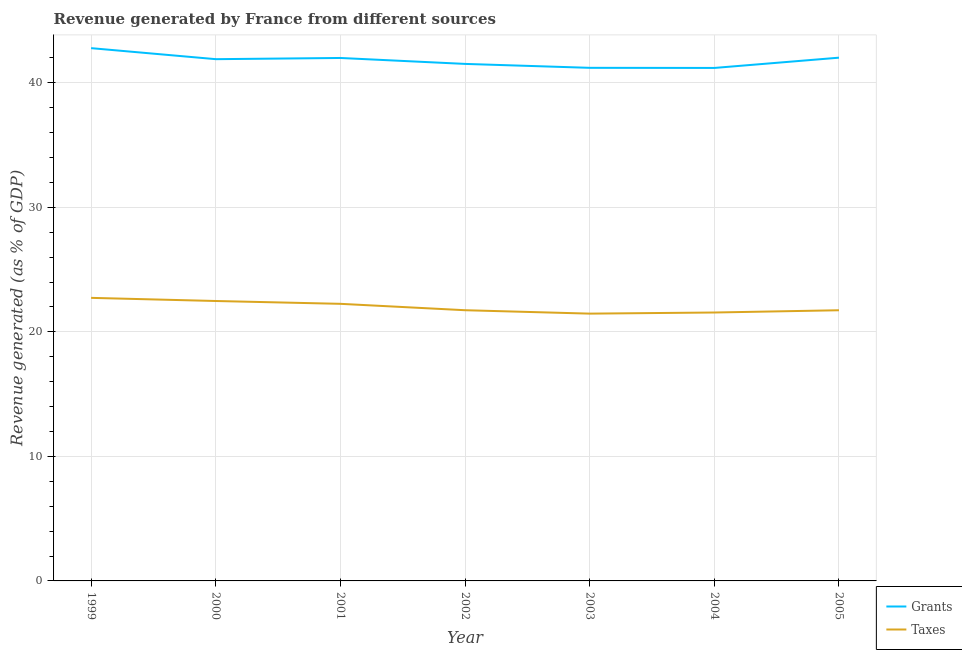Is the number of lines equal to the number of legend labels?
Your response must be concise. Yes. What is the revenue generated by taxes in 2002?
Your response must be concise. 21.74. Across all years, what is the maximum revenue generated by grants?
Provide a short and direct response. 42.78. Across all years, what is the minimum revenue generated by grants?
Make the answer very short. 41.19. What is the total revenue generated by grants in the graph?
Keep it short and to the point. 292.58. What is the difference between the revenue generated by taxes in 2004 and that in 2005?
Your response must be concise. -0.18. What is the difference between the revenue generated by grants in 2000 and the revenue generated by taxes in 2005?
Offer a terse response. 20.16. What is the average revenue generated by taxes per year?
Offer a terse response. 21.99. In the year 2004, what is the difference between the revenue generated by grants and revenue generated by taxes?
Ensure brevity in your answer.  19.64. What is the ratio of the revenue generated by taxes in 2002 to that in 2004?
Keep it short and to the point. 1.01. Is the revenue generated by grants in 2001 less than that in 2002?
Your response must be concise. No. Is the difference between the revenue generated by taxes in 1999 and 2000 greater than the difference between the revenue generated by grants in 1999 and 2000?
Your response must be concise. No. What is the difference between the highest and the second highest revenue generated by taxes?
Make the answer very short. 0.25. What is the difference between the highest and the lowest revenue generated by taxes?
Give a very brief answer. 1.27. Does the revenue generated by taxes monotonically increase over the years?
Your answer should be compact. No. Is the revenue generated by taxes strictly less than the revenue generated by grants over the years?
Make the answer very short. Yes. Are the values on the major ticks of Y-axis written in scientific E-notation?
Make the answer very short. No. Does the graph contain any zero values?
Give a very brief answer. No. Does the graph contain grids?
Offer a very short reply. Yes. Where does the legend appear in the graph?
Give a very brief answer. Bottom right. What is the title of the graph?
Give a very brief answer. Revenue generated by France from different sources. Does "Researchers" appear as one of the legend labels in the graph?
Your answer should be compact. No. What is the label or title of the Y-axis?
Provide a succinct answer. Revenue generated (as % of GDP). What is the Revenue generated (as % of GDP) of Grants in 1999?
Make the answer very short. 42.78. What is the Revenue generated (as % of GDP) in Taxes in 1999?
Offer a very short reply. 22.73. What is the Revenue generated (as % of GDP) of Grants in 2000?
Provide a short and direct response. 41.89. What is the Revenue generated (as % of GDP) of Taxes in 2000?
Offer a terse response. 22.48. What is the Revenue generated (as % of GDP) in Grants in 2001?
Offer a terse response. 41.99. What is the Revenue generated (as % of GDP) in Taxes in 2001?
Offer a very short reply. 22.25. What is the Revenue generated (as % of GDP) in Grants in 2002?
Offer a terse response. 41.51. What is the Revenue generated (as % of GDP) in Taxes in 2002?
Your response must be concise. 21.74. What is the Revenue generated (as % of GDP) in Grants in 2003?
Keep it short and to the point. 41.2. What is the Revenue generated (as % of GDP) in Taxes in 2003?
Give a very brief answer. 21.46. What is the Revenue generated (as % of GDP) of Grants in 2004?
Provide a succinct answer. 41.19. What is the Revenue generated (as % of GDP) of Taxes in 2004?
Provide a succinct answer. 21.55. What is the Revenue generated (as % of GDP) of Grants in 2005?
Give a very brief answer. 42.01. What is the Revenue generated (as % of GDP) of Taxes in 2005?
Provide a short and direct response. 21.73. Across all years, what is the maximum Revenue generated (as % of GDP) of Grants?
Give a very brief answer. 42.78. Across all years, what is the maximum Revenue generated (as % of GDP) of Taxes?
Provide a short and direct response. 22.73. Across all years, what is the minimum Revenue generated (as % of GDP) in Grants?
Your answer should be very brief. 41.19. Across all years, what is the minimum Revenue generated (as % of GDP) in Taxes?
Your answer should be compact. 21.46. What is the total Revenue generated (as % of GDP) in Grants in the graph?
Ensure brevity in your answer.  292.58. What is the total Revenue generated (as % of GDP) in Taxes in the graph?
Give a very brief answer. 153.94. What is the difference between the Revenue generated (as % of GDP) of Grants in 1999 and that in 2000?
Your answer should be compact. 0.88. What is the difference between the Revenue generated (as % of GDP) in Taxes in 1999 and that in 2000?
Offer a terse response. 0.25. What is the difference between the Revenue generated (as % of GDP) in Grants in 1999 and that in 2001?
Ensure brevity in your answer.  0.79. What is the difference between the Revenue generated (as % of GDP) of Taxes in 1999 and that in 2001?
Give a very brief answer. 0.48. What is the difference between the Revenue generated (as % of GDP) of Grants in 1999 and that in 2002?
Your answer should be very brief. 1.27. What is the difference between the Revenue generated (as % of GDP) of Taxes in 1999 and that in 2002?
Your response must be concise. 0.99. What is the difference between the Revenue generated (as % of GDP) of Grants in 1999 and that in 2003?
Your answer should be very brief. 1.58. What is the difference between the Revenue generated (as % of GDP) in Taxes in 1999 and that in 2003?
Ensure brevity in your answer.  1.27. What is the difference between the Revenue generated (as % of GDP) of Grants in 1999 and that in 2004?
Your answer should be compact. 1.59. What is the difference between the Revenue generated (as % of GDP) of Taxes in 1999 and that in 2004?
Make the answer very short. 1.18. What is the difference between the Revenue generated (as % of GDP) in Grants in 1999 and that in 2005?
Offer a terse response. 0.76. What is the difference between the Revenue generated (as % of GDP) of Grants in 2000 and that in 2001?
Give a very brief answer. -0.1. What is the difference between the Revenue generated (as % of GDP) of Taxes in 2000 and that in 2001?
Your answer should be very brief. 0.23. What is the difference between the Revenue generated (as % of GDP) of Grants in 2000 and that in 2002?
Your response must be concise. 0.38. What is the difference between the Revenue generated (as % of GDP) in Taxes in 2000 and that in 2002?
Provide a succinct answer. 0.74. What is the difference between the Revenue generated (as % of GDP) in Grants in 2000 and that in 2003?
Your answer should be compact. 0.7. What is the difference between the Revenue generated (as % of GDP) in Taxes in 2000 and that in 2003?
Make the answer very short. 1.01. What is the difference between the Revenue generated (as % of GDP) of Grants in 2000 and that in 2004?
Provide a short and direct response. 0.7. What is the difference between the Revenue generated (as % of GDP) of Taxes in 2000 and that in 2004?
Keep it short and to the point. 0.92. What is the difference between the Revenue generated (as % of GDP) in Grants in 2000 and that in 2005?
Offer a terse response. -0.12. What is the difference between the Revenue generated (as % of GDP) in Taxes in 2000 and that in 2005?
Make the answer very short. 0.74. What is the difference between the Revenue generated (as % of GDP) in Grants in 2001 and that in 2002?
Offer a terse response. 0.48. What is the difference between the Revenue generated (as % of GDP) in Taxes in 2001 and that in 2002?
Offer a very short reply. 0.51. What is the difference between the Revenue generated (as % of GDP) of Grants in 2001 and that in 2003?
Make the answer very short. 0.79. What is the difference between the Revenue generated (as % of GDP) of Taxes in 2001 and that in 2003?
Your answer should be compact. 0.79. What is the difference between the Revenue generated (as % of GDP) in Grants in 2001 and that in 2004?
Give a very brief answer. 0.8. What is the difference between the Revenue generated (as % of GDP) in Taxes in 2001 and that in 2004?
Make the answer very short. 0.7. What is the difference between the Revenue generated (as % of GDP) in Grants in 2001 and that in 2005?
Give a very brief answer. -0.02. What is the difference between the Revenue generated (as % of GDP) of Taxes in 2001 and that in 2005?
Offer a terse response. 0.52. What is the difference between the Revenue generated (as % of GDP) of Grants in 2002 and that in 2003?
Ensure brevity in your answer.  0.32. What is the difference between the Revenue generated (as % of GDP) of Taxes in 2002 and that in 2003?
Offer a very short reply. 0.27. What is the difference between the Revenue generated (as % of GDP) of Grants in 2002 and that in 2004?
Your response must be concise. 0.32. What is the difference between the Revenue generated (as % of GDP) of Taxes in 2002 and that in 2004?
Your answer should be very brief. 0.18. What is the difference between the Revenue generated (as % of GDP) of Grants in 2002 and that in 2005?
Your response must be concise. -0.5. What is the difference between the Revenue generated (as % of GDP) of Taxes in 2002 and that in 2005?
Provide a succinct answer. 0. What is the difference between the Revenue generated (as % of GDP) of Grants in 2003 and that in 2004?
Your response must be concise. 0.01. What is the difference between the Revenue generated (as % of GDP) in Taxes in 2003 and that in 2004?
Offer a very short reply. -0.09. What is the difference between the Revenue generated (as % of GDP) of Grants in 2003 and that in 2005?
Ensure brevity in your answer.  -0.82. What is the difference between the Revenue generated (as % of GDP) in Taxes in 2003 and that in 2005?
Keep it short and to the point. -0.27. What is the difference between the Revenue generated (as % of GDP) in Grants in 2004 and that in 2005?
Provide a short and direct response. -0.82. What is the difference between the Revenue generated (as % of GDP) of Taxes in 2004 and that in 2005?
Offer a very short reply. -0.18. What is the difference between the Revenue generated (as % of GDP) of Grants in 1999 and the Revenue generated (as % of GDP) of Taxes in 2000?
Keep it short and to the point. 20.3. What is the difference between the Revenue generated (as % of GDP) in Grants in 1999 and the Revenue generated (as % of GDP) in Taxes in 2001?
Offer a terse response. 20.53. What is the difference between the Revenue generated (as % of GDP) in Grants in 1999 and the Revenue generated (as % of GDP) in Taxes in 2002?
Your answer should be very brief. 21.04. What is the difference between the Revenue generated (as % of GDP) in Grants in 1999 and the Revenue generated (as % of GDP) in Taxes in 2003?
Your answer should be compact. 21.32. What is the difference between the Revenue generated (as % of GDP) in Grants in 1999 and the Revenue generated (as % of GDP) in Taxes in 2004?
Ensure brevity in your answer.  21.23. What is the difference between the Revenue generated (as % of GDP) in Grants in 1999 and the Revenue generated (as % of GDP) in Taxes in 2005?
Give a very brief answer. 21.05. What is the difference between the Revenue generated (as % of GDP) in Grants in 2000 and the Revenue generated (as % of GDP) in Taxes in 2001?
Make the answer very short. 19.65. What is the difference between the Revenue generated (as % of GDP) in Grants in 2000 and the Revenue generated (as % of GDP) in Taxes in 2002?
Your answer should be compact. 20.16. What is the difference between the Revenue generated (as % of GDP) of Grants in 2000 and the Revenue generated (as % of GDP) of Taxes in 2003?
Give a very brief answer. 20.43. What is the difference between the Revenue generated (as % of GDP) in Grants in 2000 and the Revenue generated (as % of GDP) in Taxes in 2004?
Provide a succinct answer. 20.34. What is the difference between the Revenue generated (as % of GDP) of Grants in 2000 and the Revenue generated (as % of GDP) of Taxes in 2005?
Offer a very short reply. 20.16. What is the difference between the Revenue generated (as % of GDP) in Grants in 2001 and the Revenue generated (as % of GDP) in Taxes in 2002?
Your response must be concise. 20.25. What is the difference between the Revenue generated (as % of GDP) of Grants in 2001 and the Revenue generated (as % of GDP) of Taxes in 2003?
Provide a succinct answer. 20.53. What is the difference between the Revenue generated (as % of GDP) in Grants in 2001 and the Revenue generated (as % of GDP) in Taxes in 2004?
Provide a short and direct response. 20.44. What is the difference between the Revenue generated (as % of GDP) of Grants in 2001 and the Revenue generated (as % of GDP) of Taxes in 2005?
Offer a terse response. 20.26. What is the difference between the Revenue generated (as % of GDP) of Grants in 2002 and the Revenue generated (as % of GDP) of Taxes in 2003?
Your answer should be very brief. 20.05. What is the difference between the Revenue generated (as % of GDP) in Grants in 2002 and the Revenue generated (as % of GDP) in Taxes in 2004?
Your answer should be very brief. 19.96. What is the difference between the Revenue generated (as % of GDP) in Grants in 2002 and the Revenue generated (as % of GDP) in Taxes in 2005?
Offer a very short reply. 19.78. What is the difference between the Revenue generated (as % of GDP) in Grants in 2003 and the Revenue generated (as % of GDP) in Taxes in 2004?
Your answer should be very brief. 19.65. What is the difference between the Revenue generated (as % of GDP) of Grants in 2003 and the Revenue generated (as % of GDP) of Taxes in 2005?
Give a very brief answer. 19.46. What is the difference between the Revenue generated (as % of GDP) in Grants in 2004 and the Revenue generated (as % of GDP) in Taxes in 2005?
Provide a short and direct response. 19.46. What is the average Revenue generated (as % of GDP) of Grants per year?
Give a very brief answer. 41.8. What is the average Revenue generated (as % of GDP) of Taxes per year?
Make the answer very short. 21.99. In the year 1999, what is the difference between the Revenue generated (as % of GDP) of Grants and Revenue generated (as % of GDP) of Taxes?
Make the answer very short. 20.05. In the year 2000, what is the difference between the Revenue generated (as % of GDP) in Grants and Revenue generated (as % of GDP) in Taxes?
Give a very brief answer. 19.42. In the year 2001, what is the difference between the Revenue generated (as % of GDP) in Grants and Revenue generated (as % of GDP) in Taxes?
Provide a short and direct response. 19.74. In the year 2002, what is the difference between the Revenue generated (as % of GDP) in Grants and Revenue generated (as % of GDP) in Taxes?
Your answer should be compact. 19.78. In the year 2003, what is the difference between the Revenue generated (as % of GDP) of Grants and Revenue generated (as % of GDP) of Taxes?
Provide a succinct answer. 19.74. In the year 2004, what is the difference between the Revenue generated (as % of GDP) in Grants and Revenue generated (as % of GDP) in Taxes?
Offer a very short reply. 19.64. In the year 2005, what is the difference between the Revenue generated (as % of GDP) in Grants and Revenue generated (as % of GDP) in Taxes?
Provide a short and direct response. 20.28. What is the ratio of the Revenue generated (as % of GDP) of Grants in 1999 to that in 2000?
Offer a very short reply. 1.02. What is the ratio of the Revenue generated (as % of GDP) of Taxes in 1999 to that in 2000?
Give a very brief answer. 1.01. What is the ratio of the Revenue generated (as % of GDP) in Grants in 1999 to that in 2001?
Your response must be concise. 1.02. What is the ratio of the Revenue generated (as % of GDP) of Taxes in 1999 to that in 2001?
Provide a short and direct response. 1.02. What is the ratio of the Revenue generated (as % of GDP) in Grants in 1999 to that in 2002?
Your answer should be compact. 1.03. What is the ratio of the Revenue generated (as % of GDP) in Taxes in 1999 to that in 2002?
Offer a very short reply. 1.05. What is the ratio of the Revenue generated (as % of GDP) in Grants in 1999 to that in 2003?
Your answer should be compact. 1.04. What is the ratio of the Revenue generated (as % of GDP) of Taxes in 1999 to that in 2003?
Offer a very short reply. 1.06. What is the ratio of the Revenue generated (as % of GDP) of Grants in 1999 to that in 2004?
Your answer should be compact. 1.04. What is the ratio of the Revenue generated (as % of GDP) of Taxes in 1999 to that in 2004?
Your answer should be compact. 1.05. What is the ratio of the Revenue generated (as % of GDP) of Grants in 1999 to that in 2005?
Offer a terse response. 1.02. What is the ratio of the Revenue generated (as % of GDP) in Taxes in 1999 to that in 2005?
Give a very brief answer. 1.05. What is the ratio of the Revenue generated (as % of GDP) of Taxes in 2000 to that in 2001?
Your answer should be very brief. 1.01. What is the ratio of the Revenue generated (as % of GDP) in Grants in 2000 to that in 2002?
Your answer should be very brief. 1.01. What is the ratio of the Revenue generated (as % of GDP) in Taxes in 2000 to that in 2002?
Ensure brevity in your answer.  1.03. What is the ratio of the Revenue generated (as % of GDP) of Grants in 2000 to that in 2003?
Offer a very short reply. 1.02. What is the ratio of the Revenue generated (as % of GDP) of Taxes in 2000 to that in 2003?
Offer a terse response. 1.05. What is the ratio of the Revenue generated (as % of GDP) in Grants in 2000 to that in 2004?
Give a very brief answer. 1.02. What is the ratio of the Revenue generated (as % of GDP) of Taxes in 2000 to that in 2004?
Offer a very short reply. 1.04. What is the ratio of the Revenue generated (as % of GDP) of Taxes in 2000 to that in 2005?
Keep it short and to the point. 1.03. What is the ratio of the Revenue generated (as % of GDP) in Grants in 2001 to that in 2002?
Your answer should be compact. 1.01. What is the ratio of the Revenue generated (as % of GDP) of Taxes in 2001 to that in 2002?
Offer a very short reply. 1.02. What is the ratio of the Revenue generated (as % of GDP) in Grants in 2001 to that in 2003?
Your response must be concise. 1.02. What is the ratio of the Revenue generated (as % of GDP) of Taxes in 2001 to that in 2003?
Ensure brevity in your answer.  1.04. What is the ratio of the Revenue generated (as % of GDP) in Grants in 2001 to that in 2004?
Give a very brief answer. 1.02. What is the ratio of the Revenue generated (as % of GDP) of Taxes in 2001 to that in 2004?
Your answer should be compact. 1.03. What is the ratio of the Revenue generated (as % of GDP) in Taxes in 2001 to that in 2005?
Ensure brevity in your answer.  1.02. What is the ratio of the Revenue generated (as % of GDP) of Grants in 2002 to that in 2003?
Give a very brief answer. 1.01. What is the ratio of the Revenue generated (as % of GDP) in Taxes in 2002 to that in 2003?
Your answer should be compact. 1.01. What is the ratio of the Revenue generated (as % of GDP) in Grants in 2002 to that in 2004?
Your answer should be compact. 1.01. What is the ratio of the Revenue generated (as % of GDP) of Taxes in 2002 to that in 2004?
Provide a short and direct response. 1.01. What is the ratio of the Revenue generated (as % of GDP) in Grants in 2002 to that in 2005?
Keep it short and to the point. 0.99. What is the ratio of the Revenue generated (as % of GDP) in Grants in 2003 to that in 2004?
Make the answer very short. 1. What is the ratio of the Revenue generated (as % of GDP) of Taxes in 2003 to that in 2004?
Offer a terse response. 1. What is the ratio of the Revenue generated (as % of GDP) in Grants in 2003 to that in 2005?
Give a very brief answer. 0.98. What is the ratio of the Revenue generated (as % of GDP) of Taxes in 2003 to that in 2005?
Offer a terse response. 0.99. What is the ratio of the Revenue generated (as % of GDP) in Grants in 2004 to that in 2005?
Keep it short and to the point. 0.98. What is the ratio of the Revenue generated (as % of GDP) in Taxes in 2004 to that in 2005?
Keep it short and to the point. 0.99. What is the difference between the highest and the second highest Revenue generated (as % of GDP) of Grants?
Your answer should be compact. 0.76. What is the difference between the highest and the second highest Revenue generated (as % of GDP) of Taxes?
Your response must be concise. 0.25. What is the difference between the highest and the lowest Revenue generated (as % of GDP) in Grants?
Offer a very short reply. 1.59. What is the difference between the highest and the lowest Revenue generated (as % of GDP) of Taxes?
Offer a very short reply. 1.27. 